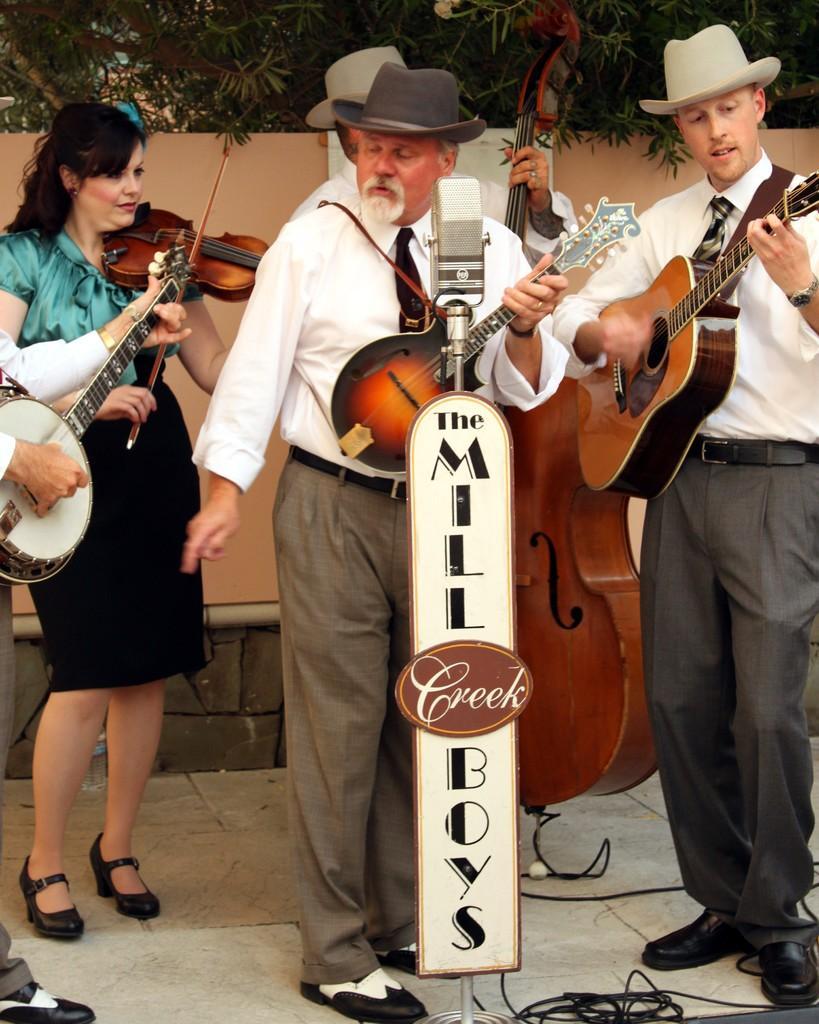Please provide a concise description of this image. In this image there are group of people who are playing the musical instrument,while the man in the middle is playing the sitar,while the man to the right side is playing the guitar,while the person to the left side is playing the sitar, and the woman at the back side is playing the violin. There is a mic in front of them. At the back side there are trees. 